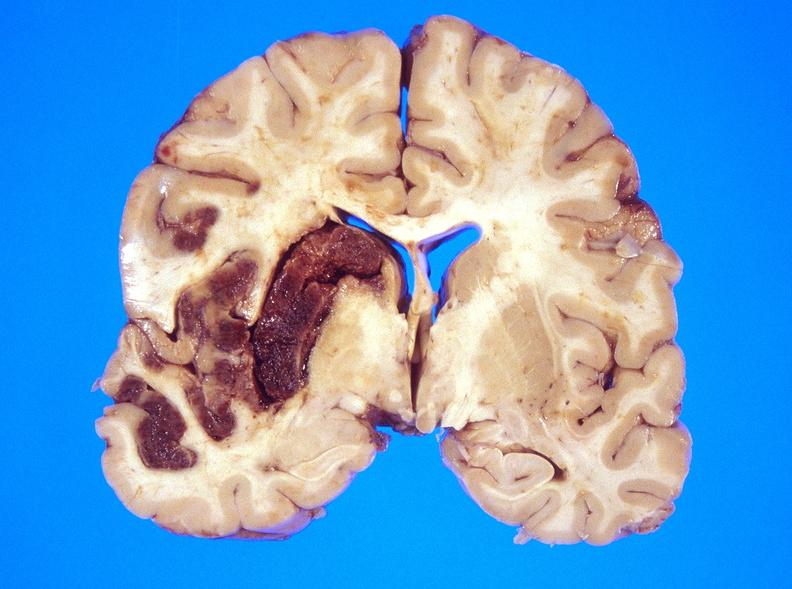s blood present?
Answer the question using a single word or phrase. No 